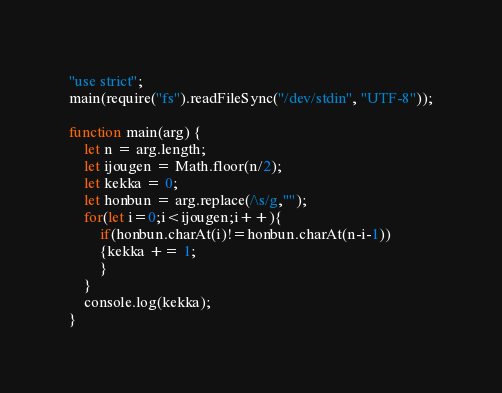Convert code to text. <code><loc_0><loc_0><loc_500><loc_500><_JavaScript_>"use strict";
main(require("fs").readFileSync("/dev/stdin", "UTF-8"));

function main(arg) {
    let n = arg.length;
    let ijougen = Math.floor(n/2);
    let kekka = 0;
    let honbun = arg.replace(/\s/g,"");
    for(let i=0;i<ijougen;i++){
    	if(honbun.charAt(i)!=honbun.charAt(n-i-1))
        {kekka += 1;
        }
    }
    console.log(kekka);
}</code> 